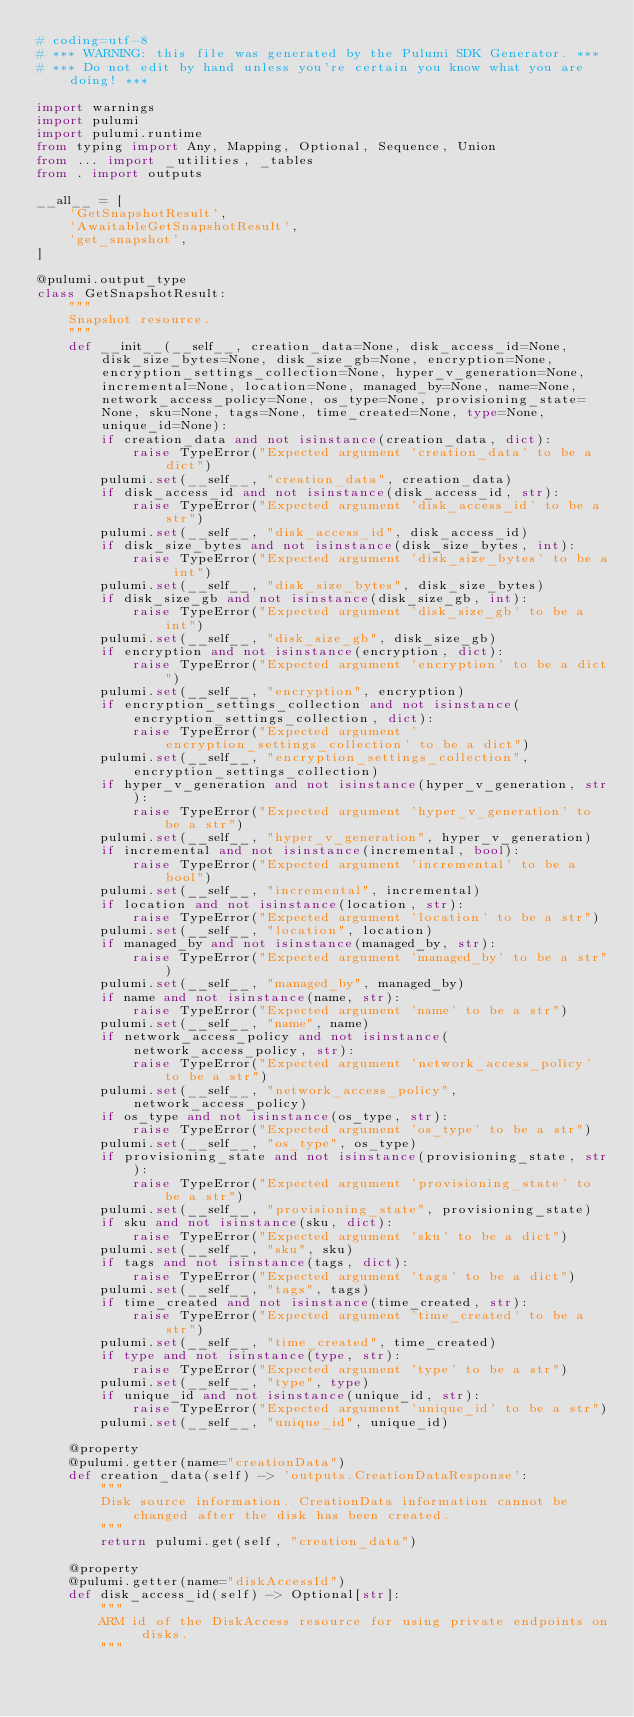Convert code to text. <code><loc_0><loc_0><loc_500><loc_500><_Python_># coding=utf-8
# *** WARNING: this file was generated by the Pulumi SDK Generator. ***
# *** Do not edit by hand unless you're certain you know what you are doing! ***

import warnings
import pulumi
import pulumi.runtime
from typing import Any, Mapping, Optional, Sequence, Union
from ... import _utilities, _tables
from . import outputs

__all__ = [
    'GetSnapshotResult',
    'AwaitableGetSnapshotResult',
    'get_snapshot',
]

@pulumi.output_type
class GetSnapshotResult:
    """
    Snapshot resource.
    """
    def __init__(__self__, creation_data=None, disk_access_id=None, disk_size_bytes=None, disk_size_gb=None, encryption=None, encryption_settings_collection=None, hyper_v_generation=None, incremental=None, location=None, managed_by=None, name=None, network_access_policy=None, os_type=None, provisioning_state=None, sku=None, tags=None, time_created=None, type=None, unique_id=None):
        if creation_data and not isinstance(creation_data, dict):
            raise TypeError("Expected argument 'creation_data' to be a dict")
        pulumi.set(__self__, "creation_data", creation_data)
        if disk_access_id and not isinstance(disk_access_id, str):
            raise TypeError("Expected argument 'disk_access_id' to be a str")
        pulumi.set(__self__, "disk_access_id", disk_access_id)
        if disk_size_bytes and not isinstance(disk_size_bytes, int):
            raise TypeError("Expected argument 'disk_size_bytes' to be a int")
        pulumi.set(__self__, "disk_size_bytes", disk_size_bytes)
        if disk_size_gb and not isinstance(disk_size_gb, int):
            raise TypeError("Expected argument 'disk_size_gb' to be a int")
        pulumi.set(__self__, "disk_size_gb", disk_size_gb)
        if encryption and not isinstance(encryption, dict):
            raise TypeError("Expected argument 'encryption' to be a dict")
        pulumi.set(__self__, "encryption", encryption)
        if encryption_settings_collection and not isinstance(encryption_settings_collection, dict):
            raise TypeError("Expected argument 'encryption_settings_collection' to be a dict")
        pulumi.set(__self__, "encryption_settings_collection", encryption_settings_collection)
        if hyper_v_generation and not isinstance(hyper_v_generation, str):
            raise TypeError("Expected argument 'hyper_v_generation' to be a str")
        pulumi.set(__self__, "hyper_v_generation", hyper_v_generation)
        if incremental and not isinstance(incremental, bool):
            raise TypeError("Expected argument 'incremental' to be a bool")
        pulumi.set(__self__, "incremental", incremental)
        if location and not isinstance(location, str):
            raise TypeError("Expected argument 'location' to be a str")
        pulumi.set(__self__, "location", location)
        if managed_by and not isinstance(managed_by, str):
            raise TypeError("Expected argument 'managed_by' to be a str")
        pulumi.set(__self__, "managed_by", managed_by)
        if name and not isinstance(name, str):
            raise TypeError("Expected argument 'name' to be a str")
        pulumi.set(__self__, "name", name)
        if network_access_policy and not isinstance(network_access_policy, str):
            raise TypeError("Expected argument 'network_access_policy' to be a str")
        pulumi.set(__self__, "network_access_policy", network_access_policy)
        if os_type and not isinstance(os_type, str):
            raise TypeError("Expected argument 'os_type' to be a str")
        pulumi.set(__self__, "os_type", os_type)
        if provisioning_state and not isinstance(provisioning_state, str):
            raise TypeError("Expected argument 'provisioning_state' to be a str")
        pulumi.set(__self__, "provisioning_state", provisioning_state)
        if sku and not isinstance(sku, dict):
            raise TypeError("Expected argument 'sku' to be a dict")
        pulumi.set(__self__, "sku", sku)
        if tags and not isinstance(tags, dict):
            raise TypeError("Expected argument 'tags' to be a dict")
        pulumi.set(__self__, "tags", tags)
        if time_created and not isinstance(time_created, str):
            raise TypeError("Expected argument 'time_created' to be a str")
        pulumi.set(__self__, "time_created", time_created)
        if type and not isinstance(type, str):
            raise TypeError("Expected argument 'type' to be a str")
        pulumi.set(__self__, "type", type)
        if unique_id and not isinstance(unique_id, str):
            raise TypeError("Expected argument 'unique_id' to be a str")
        pulumi.set(__self__, "unique_id", unique_id)

    @property
    @pulumi.getter(name="creationData")
    def creation_data(self) -> 'outputs.CreationDataResponse':
        """
        Disk source information. CreationData information cannot be changed after the disk has been created.
        """
        return pulumi.get(self, "creation_data")

    @property
    @pulumi.getter(name="diskAccessId")
    def disk_access_id(self) -> Optional[str]:
        """
        ARM id of the DiskAccess resource for using private endpoints on disks.
        """</code> 